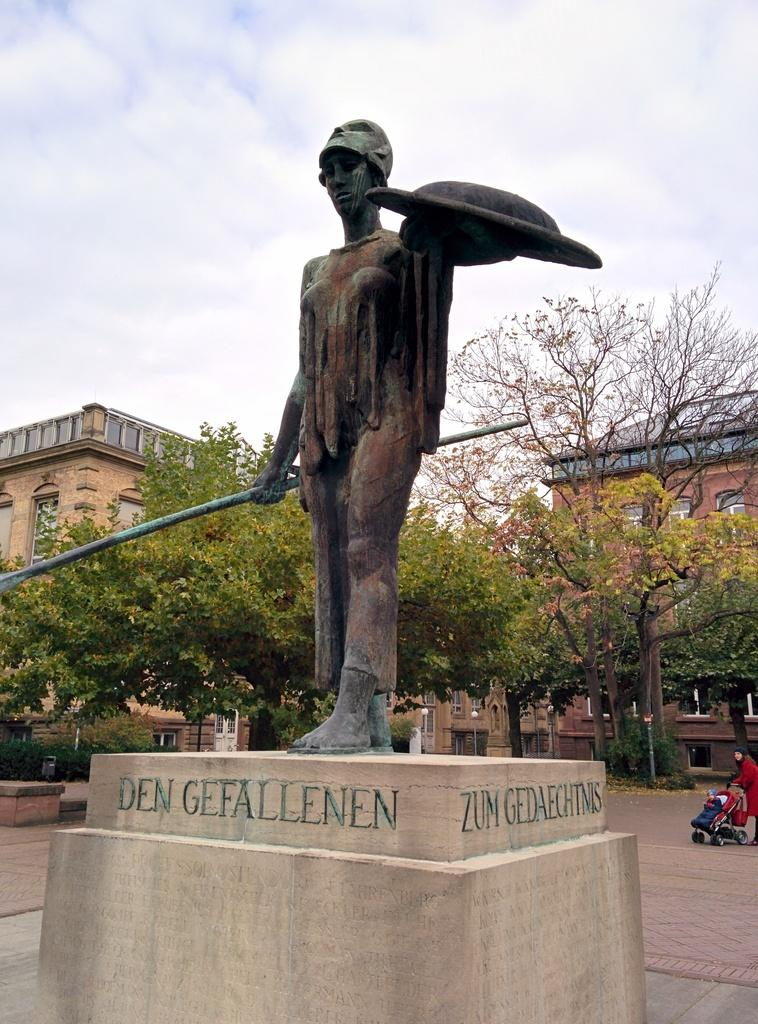What is the main subject in the image? There is a statue of a human in the image. What else can be seen in the image besides the statue? Trees are present in the image. Can you describe the woman in the image? There is a woman walking in the image, and she is wearing a red color dress. What type of shop can be seen in the background of the image? There is no shop present in the image; it features a statue, trees, and a woman walking. Can you tell me how many leaves are on the trees in the image? The number of leaves on the trees cannot be determined from the image, as it only provides a general view of the trees. 